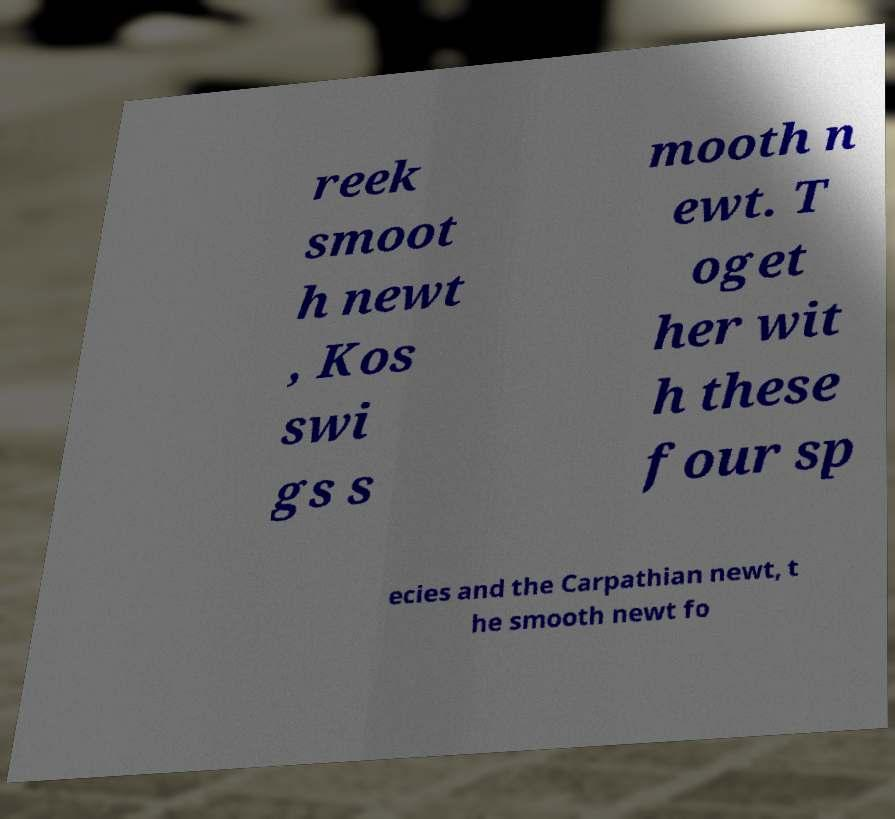Please identify and transcribe the text found in this image. reek smoot h newt , Kos swi gs s mooth n ewt. T oget her wit h these four sp ecies and the Carpathian newt, t he smooth newt fo 